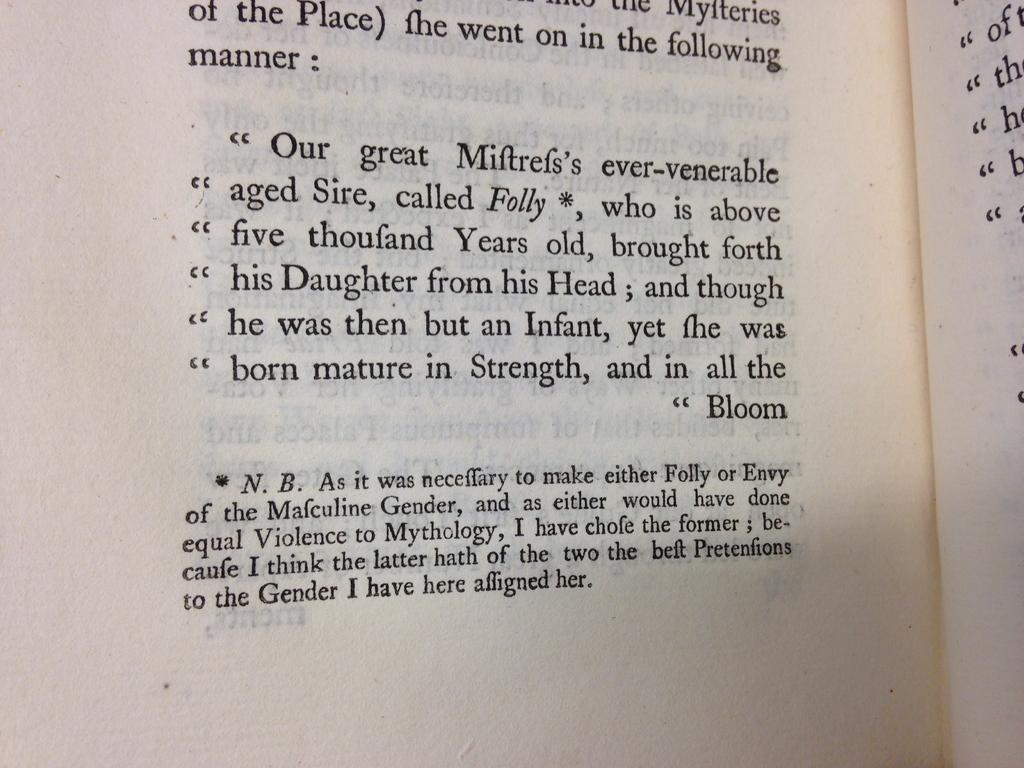<image>
Create a compact narrative representing the image presented. A book open to a quote that begins "Our great Miftrefs's ever-venerable aged Sire" 